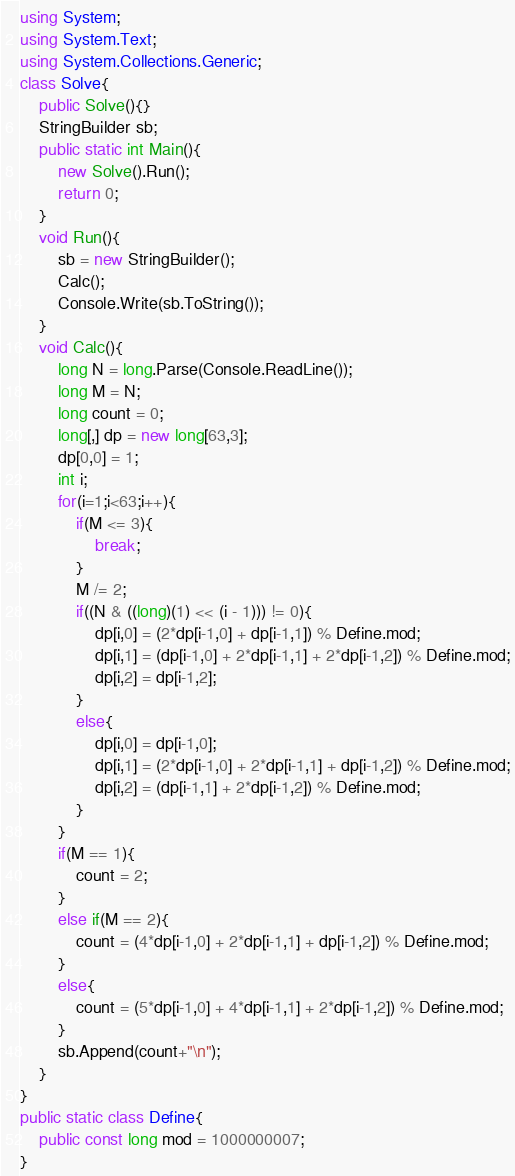<code> <loc_0><loc_0><loc_500><loc_500><_C#_>using System;
using System.Text;
using System.Collections.Generic;
class Solve{
    public Solve(){}
    StringBuilder sb;
    public static int Main(){
        new Solve().Run();
        return 0;
    }
    void Run(){
        sb = new StringBuilder();
        Calc();
        Console.Write(sb.ToString());
    }
    void Calc(){
        long N = long.Parse(Console.ReadLine());
        long M = N;
        long count = 0;
        long[,] dp = new long[63,3];
        dp[0,0] = 1;
        int i;
        for(i=1;i<63;i++){
            if(M <= 3){
                break;
            }
            M /= 2;
            if((N & ((long)(1) << (i - 1))) != 0){
                dp[i,0] = (2*dp[i-1,0] + dp[i-1,1]) % Define.mod;
                dp[i,1] = (dp[i-1,0] + 2*dp[i-1,1] + 2*dp[i-1,2]) % Define.mod;
                dp[i,2] = dp[i-1,2]; 
            }
            else{
                dp[i,0] = dp[i-1,0];
                dp[i,1] = (2*dp[i-1,0] + 2*dp[i-1,1] + dp[i-1,2]) % Define.mod;
                dp[i,2] = (dp[i-1,1] + 2*dp[i-1,2]) % Define.mod;
            }
        }
        if(M == 1){
            count = 2;
        }
        else if(M == 2){
            count = (4*dp[i-1,0] + 2*dp[i-1,1] + dp[i-1,2]) % Define.mod;
        }
        else{
            count = (5*dp[i-1,0] + 4*dp[i-1,1] + 2*dp[i-1,2]) % Define.mod;
        }
        sb.Append(count+"\n");
    }
}
public static class Define{
    public const long mod = 1000000007;
}</code> 